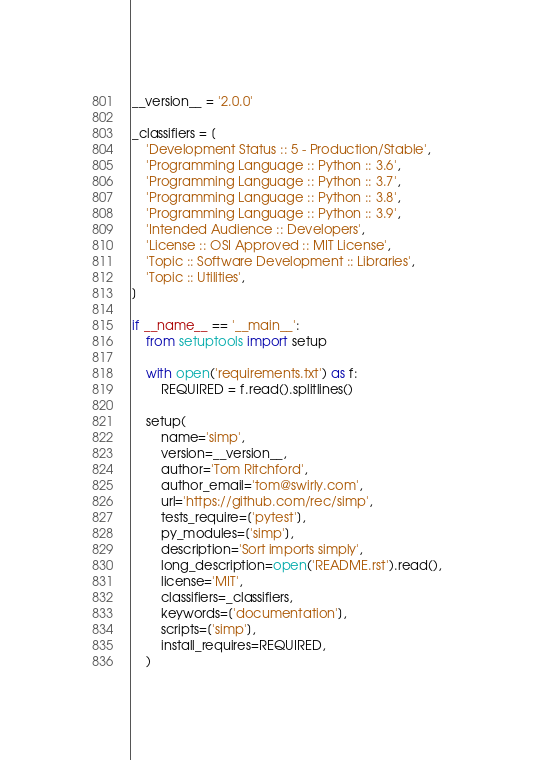Convert code to text. <code><loc_0><loc_0><loc_500><loc_500><_Python_>__version__ = '2.0.0'

_classifiers = [
    'Development Status :: 5 - Production/Stable',
    'Programming Language :: Python :: 3.6',
    'Programming Language :: Python :: 3.7',
    'Programming Language :: Python :: 3.8',
    'Programming Language :: Python :: 3.9',
    'Intended Audience :: Developers',
    'License :: OSI Approved :: MIT License',
    'Topic :: Software Development :: Libraries',
    'Topic :: Utilities',
]

if __name__ == '__main__':
    from setuptools import setup

    with open('requirements.txt') as f:
        REQUIRED = f.read().splitlines()

    setup(
        name='simp',
        version=__version__,
        author='Tom Ritchford',
        author_email='tom@swirly.com',
        url='https://github.com/rec/simp',
        tests_require=['pytest'],
        py_modules=['simp'],
        description='Sort imports simply',
        long_description=open('README.rst').read(),
        license='MIT',
        classifiers=_classifiers,
        keywords=['documentation'],
        scripts=['simp'],
        install_requires=REQUIRED,
    )
</code> 